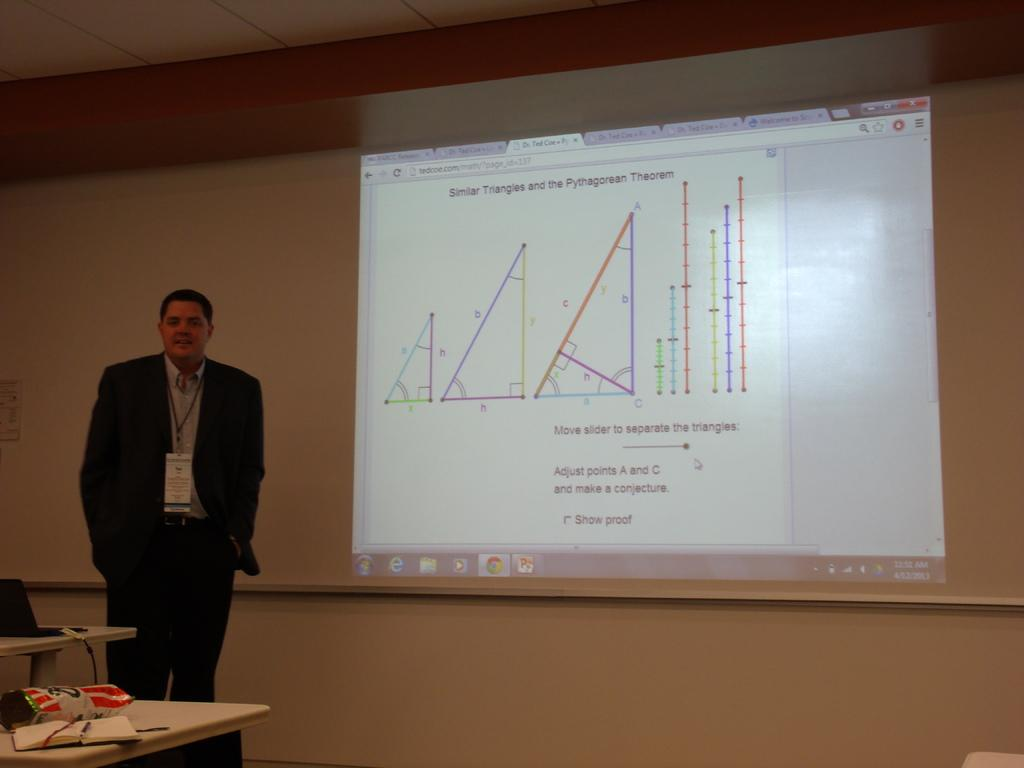What is the main subject of the image? There is a man standing in the image. What can be seen behind the man? There is a screen in the image. What is the man standing near? There is a table in the image. What object is on the table? There is a book on the table in the image. What channel is the man watching on the screen? There is no information about the content on the screen, so we cannot determine the channel being watched. 